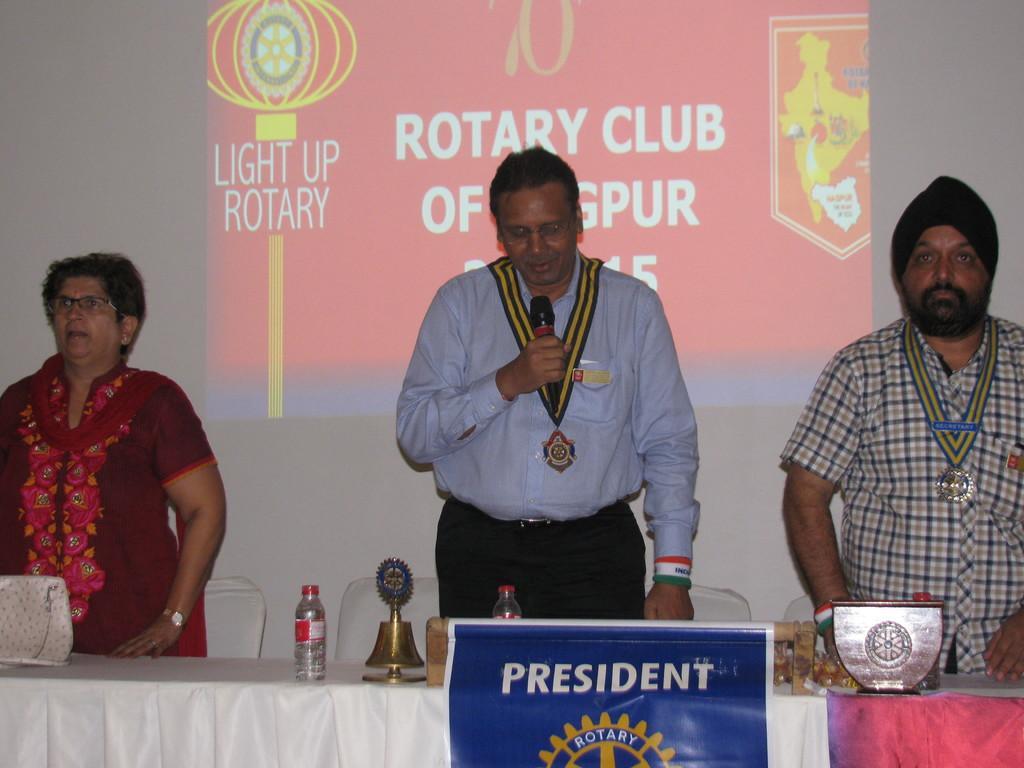Can you describe this image briefly? In this picture there are people in the center of the image and there is a table in front of them, on which there are water bottles and trophies and there is a projector screen in the background area of the image. 